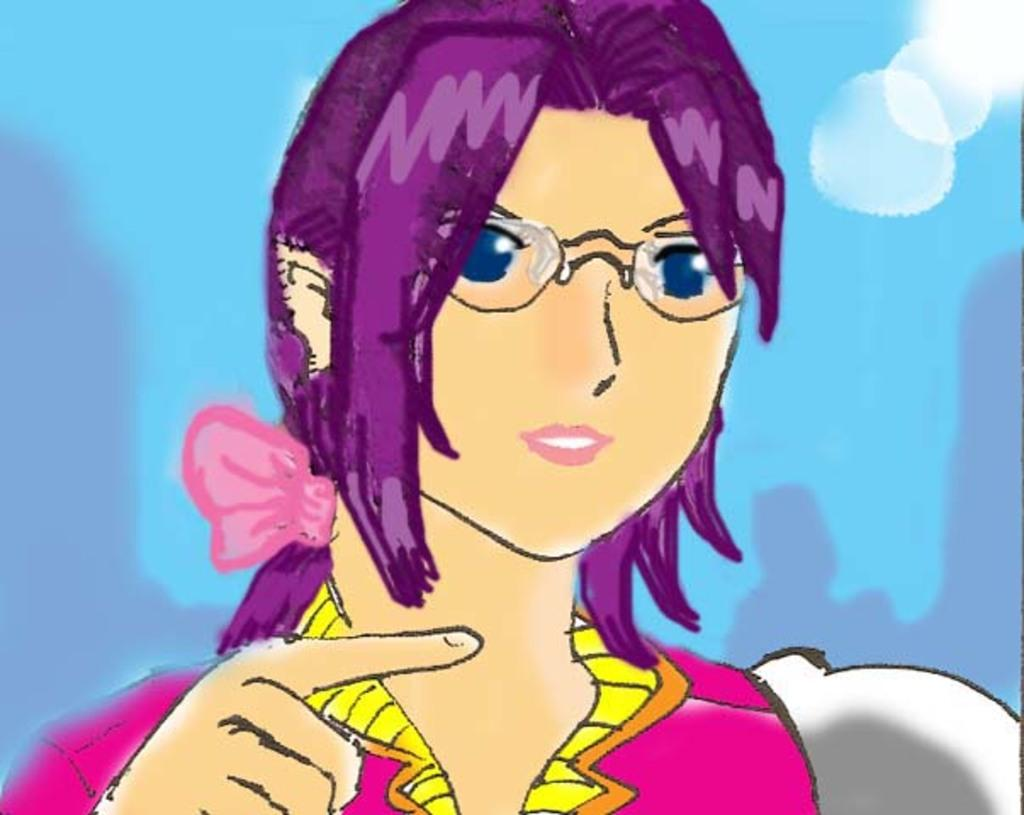What type of image is this? The image appears to be animated. Can you describe the main character in the image? There is a woman in the image. What is the woman wearing? The woman is wearing a dress and spectacles. What color is the background in the image? The background appears to be blue in color. What type of amusement can be seen in the image? There is no amusement present in the image; it features an animated woman wearing a dress and spectacles against a blue background. Is there a jail visible in the image? There is no jail present in the image. 